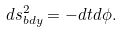<formula> <loc_0><loc_0><loc_500><loc_500>d s _ { b d y } ^ { 2 } = - d t d \phi .</formula> 